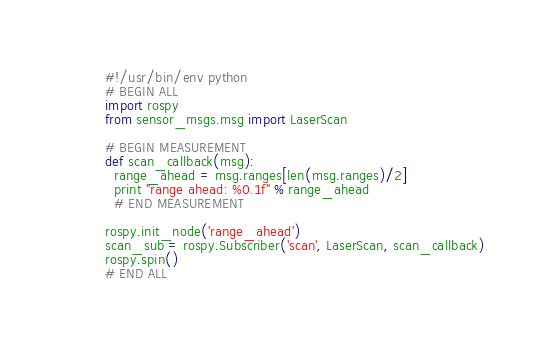<code> <loc_0><loc_0><loc_500><loc_500><_Python_>#!/usr/bin/env python
# BEGIN ALL
import rospy
from sensor_msgs.msg import LaserScan

# BEGIN MEASUREMENT
def scan_callback(msg):
  range_ahead = msg.ranges[len(msg.ranges)/2]
  print "range ahead: %0.1f" % range_ahead
  # END MEASUREMENT

rospy.init_node('range_ahead')
scan_sub = rospy.Subscriber('scan', LaserScan, scan_callback)
rospy.spin()
# END ALL
</code> 